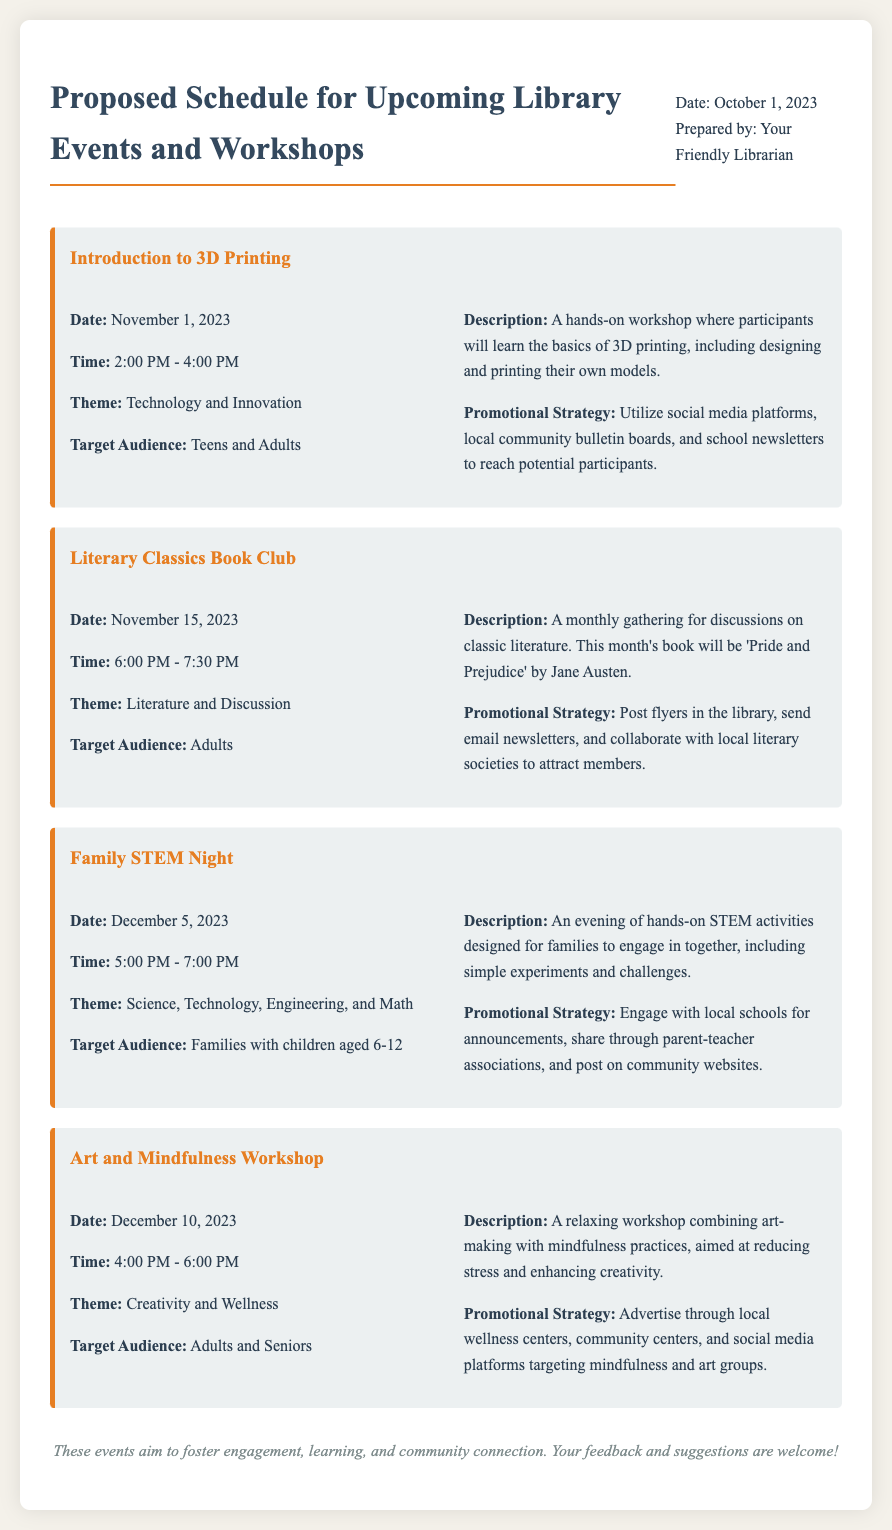What is the date of the "Introduction to 3D Printing" workshop? The date is specified in the document, which states it is on November 1, 2023.
Answer: November 1, 2023 Who is the target audience for the "Family STEM Night"? The document outlines that the target audience is families with children aged 6-12.
Answer: Families with children aged 6-12 What theme does the "Art and Mindfulness Workshop" focus on? The theme is provided in the description, indicating it is about creativity and wellness.
Answer: Creativity and Wellness How many events are listed in the document? By counting the events mentioned in the document, we find there are four events detailed.
Answer: Four What is the promotional strategy for the "Literary Classics Book Club"? The document describes using flyers, email newsletters, and collaboration with local literary societies as the promotional strategy.
Answer: Post flyers, send email newsletters, collaborate with local literary societies What time does the "Family STEM Night" start? The document notes the start time for this event is at 5:00 PM.
Answer: 5:00 PM What type of activities will be included in the "Family STEM Night"? The document mentions that the activities will include hands-on STEM activities designed for families, such as simple experiments and challenges.
Answer: Hands-on STEM activities, simple experiments, challenges What is the closing remark in the memo? The memo concludes with a statement emphasizing the aim of the events and welcoming feedback, which is specified in the closing remark section.
Answer: These events aim to foster engagement, learning, and community connection. Your feedback and suggestions are welcome! 